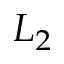<formula> <loc_0><loc_0><loc_500><loc_500>L _ { 2 }</formula> 